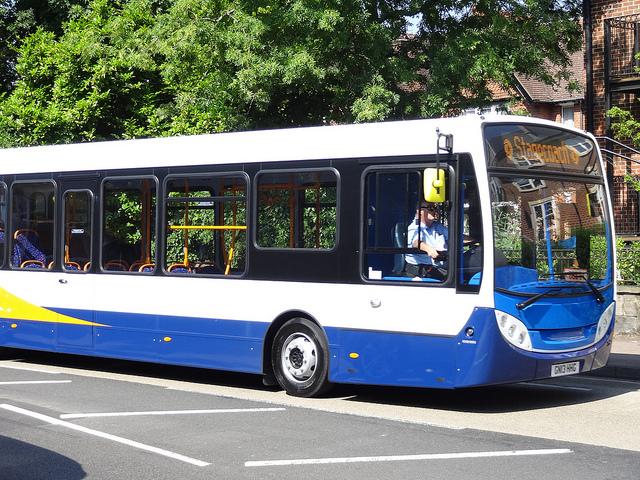Does it look like the bus driver is distracted?
Short answer required. No. Is the bus moving?
Concise answer only. No. Where is the bus?
Quick response, please. On road. 